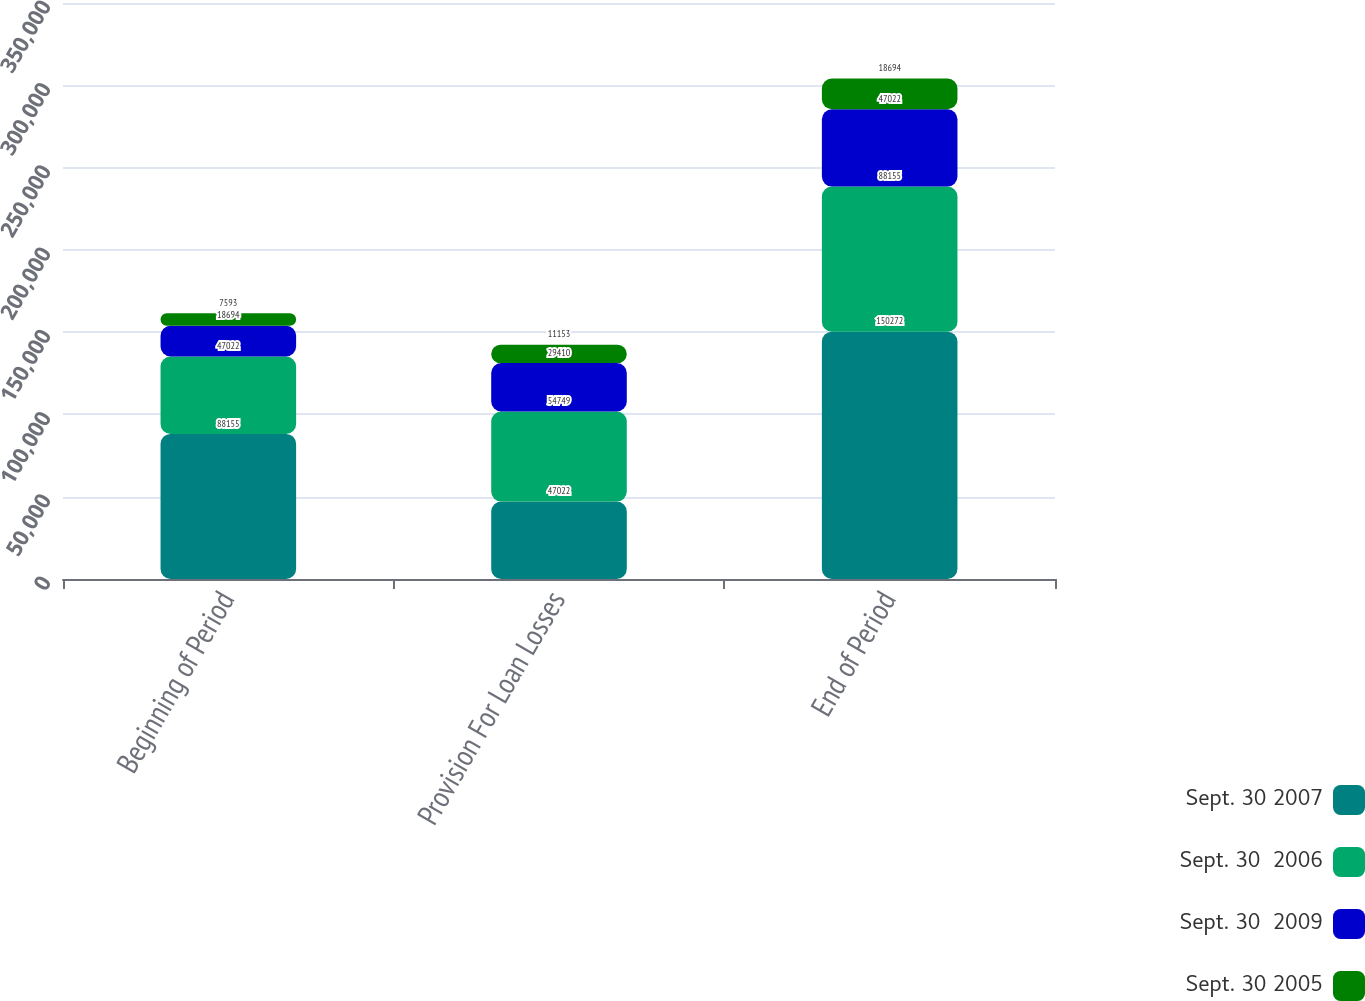Convert chart. <chart><loc_0><loc_0><loc_500><loc_500><stacked_bar_chart><ecel><fcel>Beginning of Period<fcel>Provision For Loan Losses<fcel>End of Period<nl><fcel>Sept. 30 2007<fcel>88155<fcel>47022<fcel>150272<nl><fcel>Sept. 30  2006<fcel>47022<fcel>54749<fcel>88155<nl><fcel>Sept. 30  2009<fcel>18694<fcel>29410<fcel>47022<nl><fcel>Sept. 30 2005<fcel>7593<fcel>11153<fcel>18694<nl></chart> 